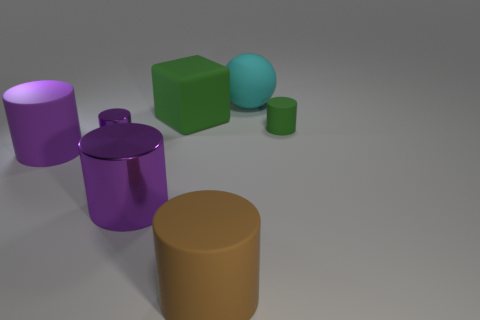Describe the texture of the surface shown in the image. The surface appears to be matte with no significant glossiness, and it seems smooth without any visible texture, indicative of a calm and simple setting. How is the lighting in the image? The lighting in the image is soft and diffuse, creating gentle shadows and giving the objects a calm, almost ethereal presence. 